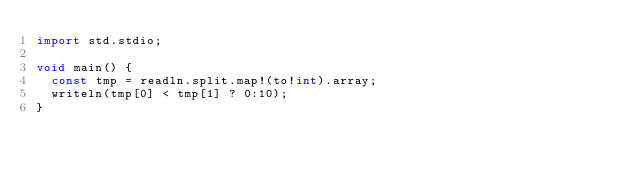Convert code to text. <code><loc_0><loc_0><loc_500><loc_500><_D_>import std.stdio;

void main() {
  const tmp = readln.split.map!(to!int).array;
  writeln(tmp[0] < tmp[1] ? 0:10);
}</code> 